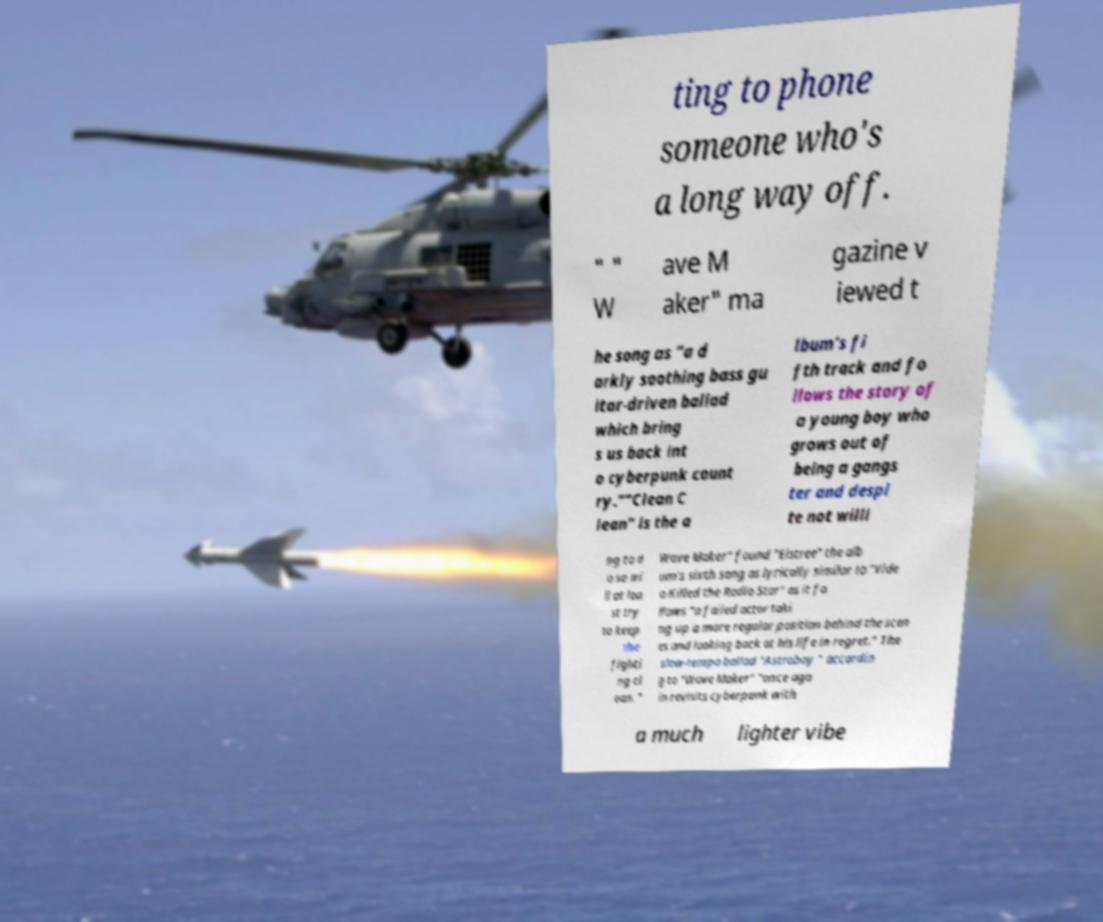For documentation purposes, I need the text within this image transcribed. Could you provide that? ting to phone someone who's a long way off. " " W ave M aker" ma gazine v iewed t he song as "a d arkly soothing bass gu itar-driven ballad which bring s us back int o cyberpunk count ry.""Clean C lean" is the a lbum's fi fth track and fo llows the story of a young boy who grows out of being a gangs ter and despi te not willi ng to d o so wi ll at lea st try to keep the fighti ng cl ean. " Wave Maker" found "Elstree" the alb um's sixth song as lyrically similar to "Vide o Killed the Radio Star" as it fo llows "a failed actor taki ng up a more regular position behind the scen es and looking back at his life in regret." The slow-tempo ballad "Astroboy " accordin g to "Wave Maker" "once aga in revisits cyberpunk with a much lighter vibe 